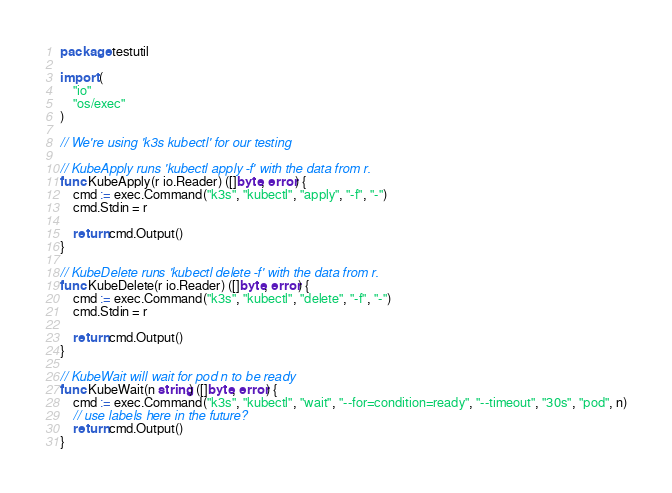<code> <loc_0><loc_0><loc_500><loc_500><_Go_>package testutil

import (
	"io"
	"os/exec"
)

// We're using 'k3s kubectl' for our testing

// KubeApply runs 'kubectl apply -f' with the data from r.
func KubeApply(r io.Reader) ([]byte, error) {
	cmd := exec.Command("k3s", "kubectl", "apply", "-f", "-")
	cmd.Stdin = r

	return cmd.Output()
}

// KubeDelete runs 'kubectl delete -f' with the data from r.
func KubeDelete(r io.Reader) ([]byte, error) {
	cmd := exec.Command("k3s", "kubectl", "delete", "-f", "-")
	cmd.Stdin = r

	return cmd.Output()
}

// KubeWait will wait for pod n to be ready
func KubeWait(n string) ([]byte, error) {
	cmd := exec.Command("k3s", "kubectl", "wait", "--for=condition=ready", "--timeout", "30s", "pod", n)
	// use labels here in the future?
	return cmd.Output()
}
</code> 